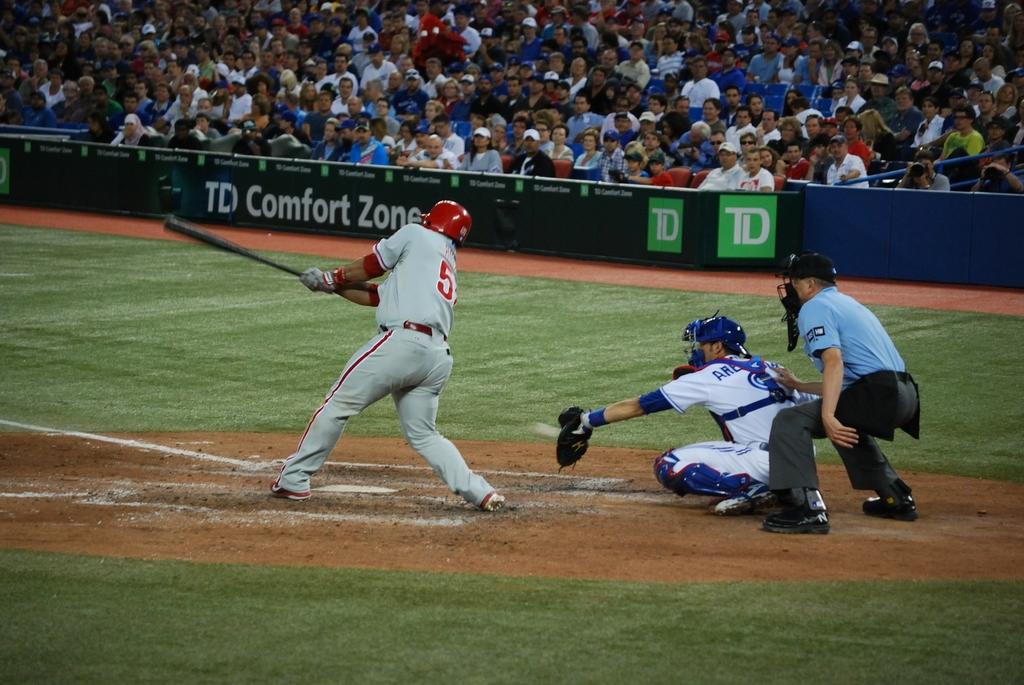What is the number of the player at bat?
Your answer should be very brief. 5. 